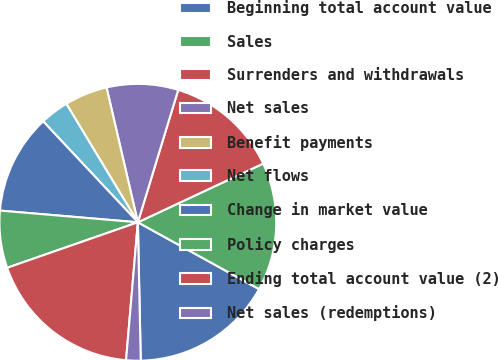<chart> <loc_0><loc_0><loc_500><loc_500><pie_chart><fcel>Beginning total account value<fcel>Sales<fcel>Surrenders and withdrawals<fcel>Net sales<fcel>Benefit payments<fcel>Net flows<fcel>Change in market value<fcel>Policy charges<fcel>Ending total account value (2)<fcel>Net sales (redemptions)<nl><fcel>16.65%<fcel>14.99%<fcel>13.32%<fcel>8.34%<fcel>5.01%<fcel>3.35%<fcel>11.66%<fcel>6.68%<fcel>18.31%<fcel>1.69%<nl></chart> 